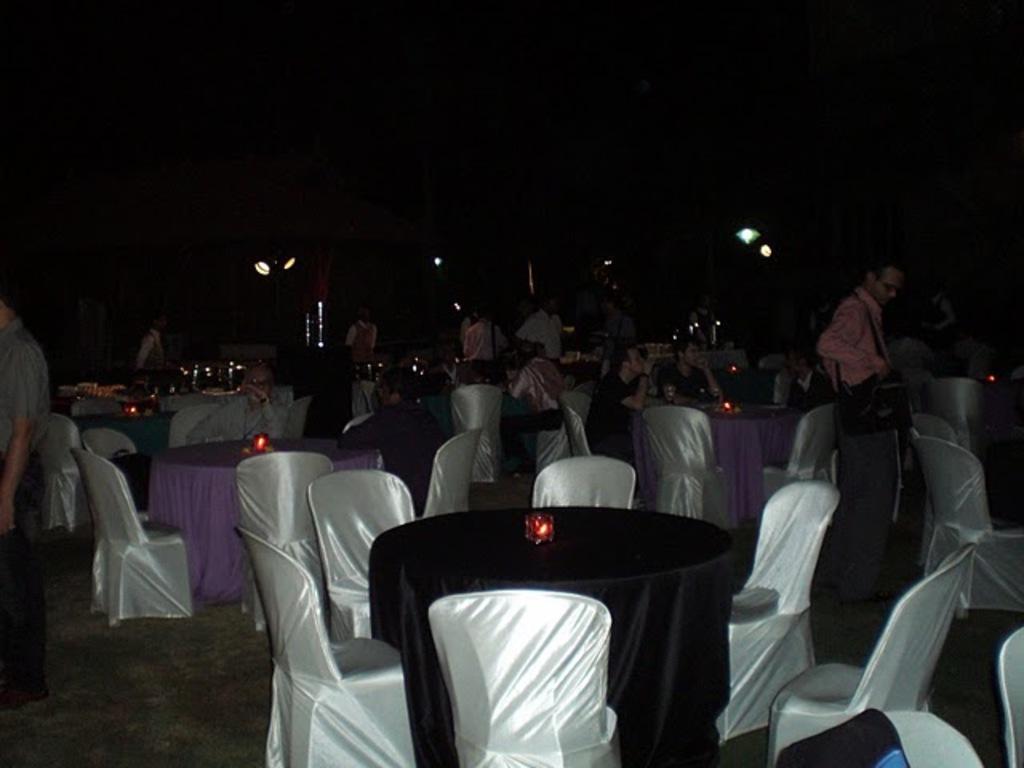Can you describe this image briefly? In this image we can see people sitting on chairs. There are few people standing. In the foreground of the image there are chairs, tables with lights on them. At the bottom of the image there is floor. 